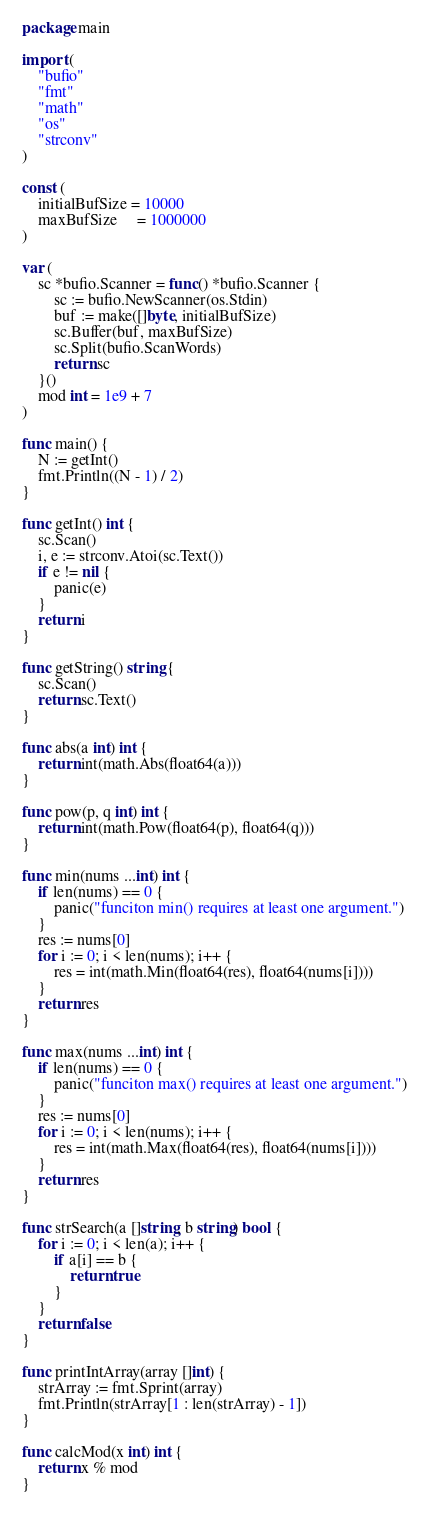Convert code to text. <code><loc_0><loc_0><loc_500><loc_500><_Go_>package main

import (
	"bufio"
	"fmt"
	"math"
	"os"
	"strconv"
)

const (
	initialBufSize = 10000
	maxBufSize     = 1000000
)

var (
	sc *bufio.Scanner = func() *bufio.Scanner {
		sc := bufio.NewScanner(os.Stdin)
		buf := make([]byte, initialBufSize)
		sc.Buffer(buf, maxBufSize)
		sc.Split(bufio.ScanWords)
		return sc
	}()
	mod int = 1e9 + 7
)

func main() {
	N := getInt()
	fmt.Println((N - 1) / 2)
}

func getInt() int {
	sc.Scan()
	i, e := strconv.Atoi(sc.Text())
	if e != nil {
		panic(e)
	}
	return i
}

func getString() string {
	sc.Scan()
	return sc.Text()
}

func abs(a int) int {
	return int(math.Abs(float64(a)))
}

func pow(p, q int) int {
	return int(math.Pow(float64(p), float64(q)))
}

func min(nums ...int) int {
	if len(nums) == 0 {
		panic("funciton min() requires at least one argument.")
	}
	res := nums[0]
	for i := 0; i < len(nums); i++ {
		res = int(math.Min(float64(res), float64(nums[i])))
	}
	return res
}

func max(nums ...int) int {
	if len(nums) == 0 {
		panic("funciton max() requires at least one argument.")
	}
	res := nums[0]
	for i := 0; i < len(nums); i++ {
		res = int(math.Max(float64(res), float64(nums[i])))
	}
	return res
}

func strSearch(a []string, b string) bool {
	for i := 0; i < len(a); i++ {
		if a[i] == b {
			return true
		}
	}
	return false
}

func printIntArray(array []int) {
	strArray := fmt.Sprint(array)
	fmt.Println(strArray[1 : len(strArray) - 1])
}

func calcMod(x int) int {
	return x % mod
}
</code> 